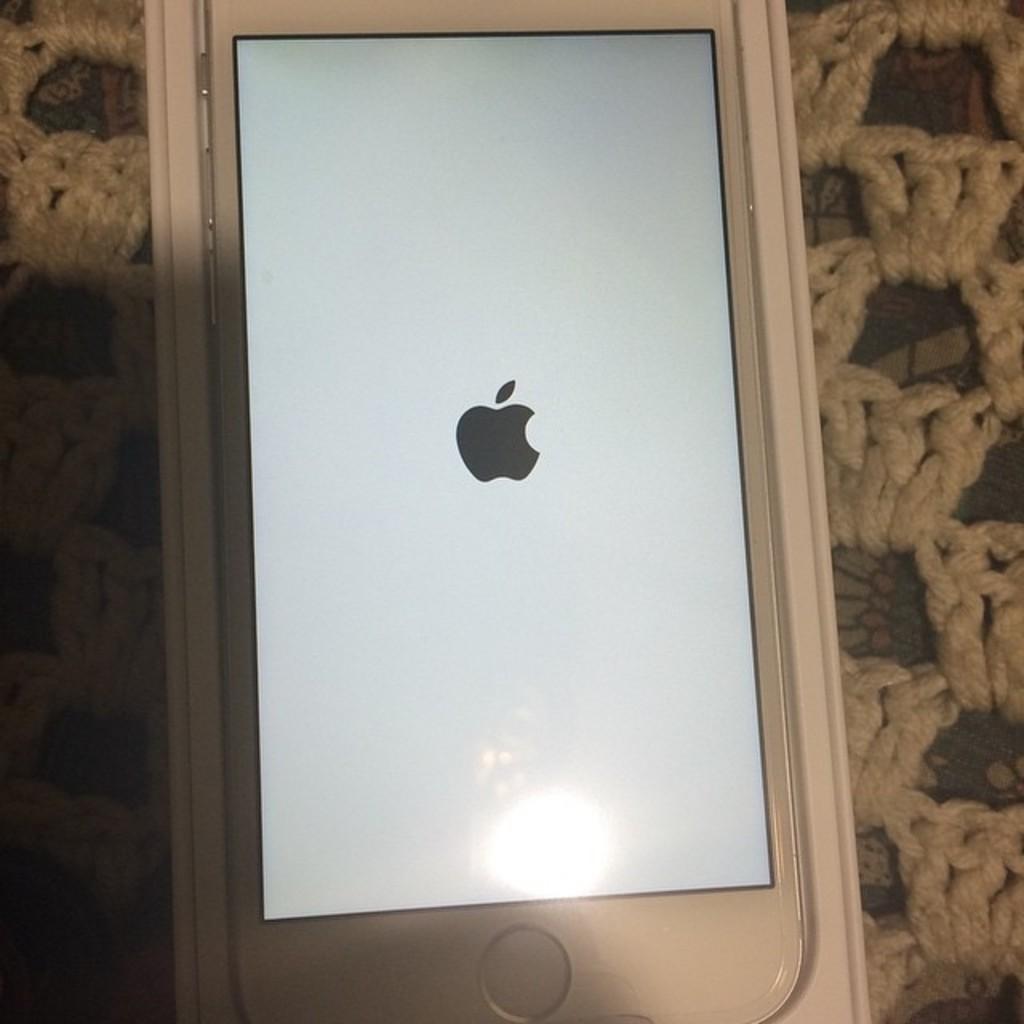Describe this image in one or two sentences. In this image I can see a white colour phone and on its screen I can see a black colour logo in the center. 